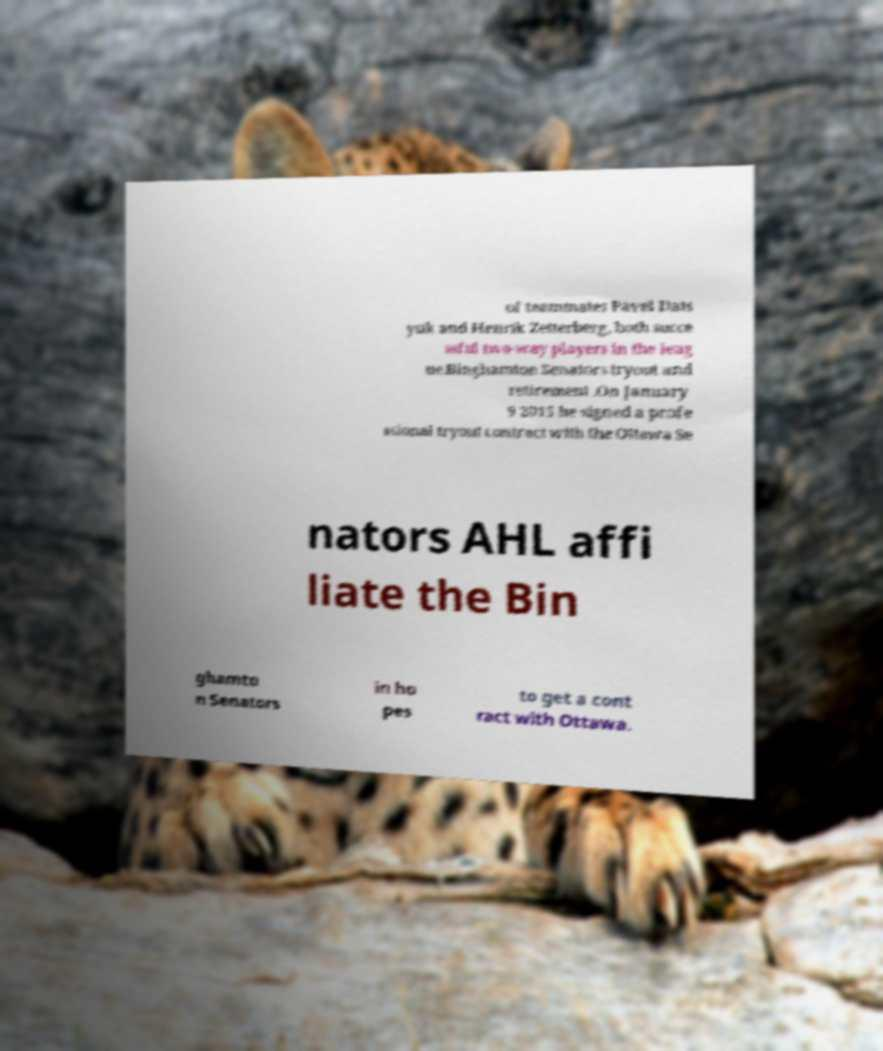Please read and relay the text visible in this image. What does it say? of teammates Pavel Dats yuk and Henrik Zetterberg, both succe ssful two-way players in the leag ue.Binghamton Senators tryout and retirement .On January 9 2015 he signed a profe ssional tryout contract with the Ottawa Se nators AHL affi liate the Bin ghamto n Senators in ho pes to get a cont ract with Ottawa. 